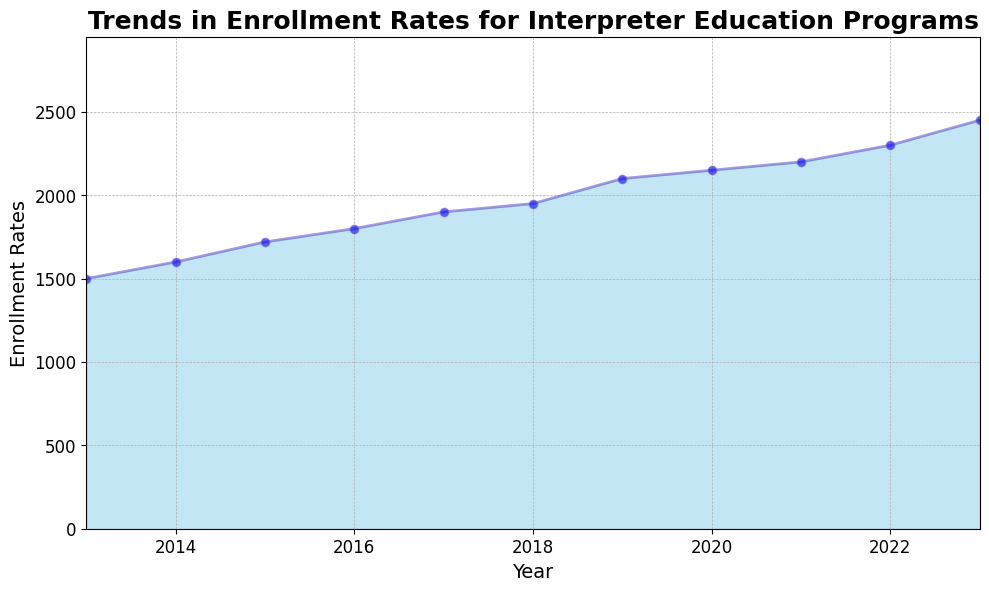what is the overall trend of enrollment rates over the last decade? The enrollment rates have generally increased each year from 2013 to 2023, indicating a consistent upward trend in popularity or demand for interpreter education programs.
Answer: Upward trend Between which two consecutive years is the largest increase in enrollment rates observed? To identify this, we compare the year-on-year differences in enrollment rates. The differences are 100 (2013-2014), 120 (2014-2015), 80 (2015-2016), 100 (2016-2017), 50 (2017-2018), 150 (2018-2019), 50 (2019-2020), 50 (2020-2021), 100 (2021-2022), and 200 (2022-2023). The largest increase is between 2022 and 2023 with a difference of 200.
Answer: 2022-2023 What is the average enrollment rate for the entire decade? Add the enrollment rates from 2013 to 2023 and divide by the number of years (11). The sum is 1500+1600+1720+1800+1900+1950+2100+2150+2200+2300+2450 = 21670. Thus, 21670 divided by 11 is approximately 1970.91.
Answer: 1970.91 Which year had the lowest enrollment rate? By looking at the plot, we can see that the lowest point on the area chart is in 2013 with an enrollment rate of 1500, which is the starting year.
Answer: 2013 By how much has the enrollment rate increased from 2013 to 2023? Subtract the enrollment rate of 2013 from that of 2023: 2450 - 1500 = 950.
Answer: 950 